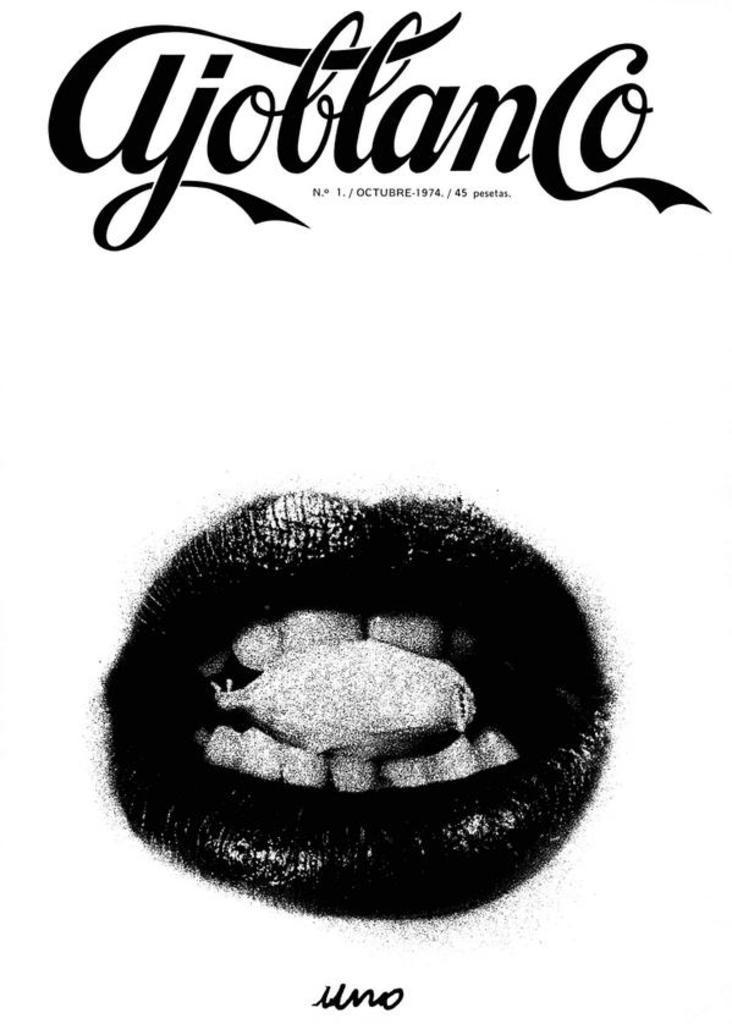Please provide a concise description of this image. In this picture we can see a poster, in the poster we can see mouth. 